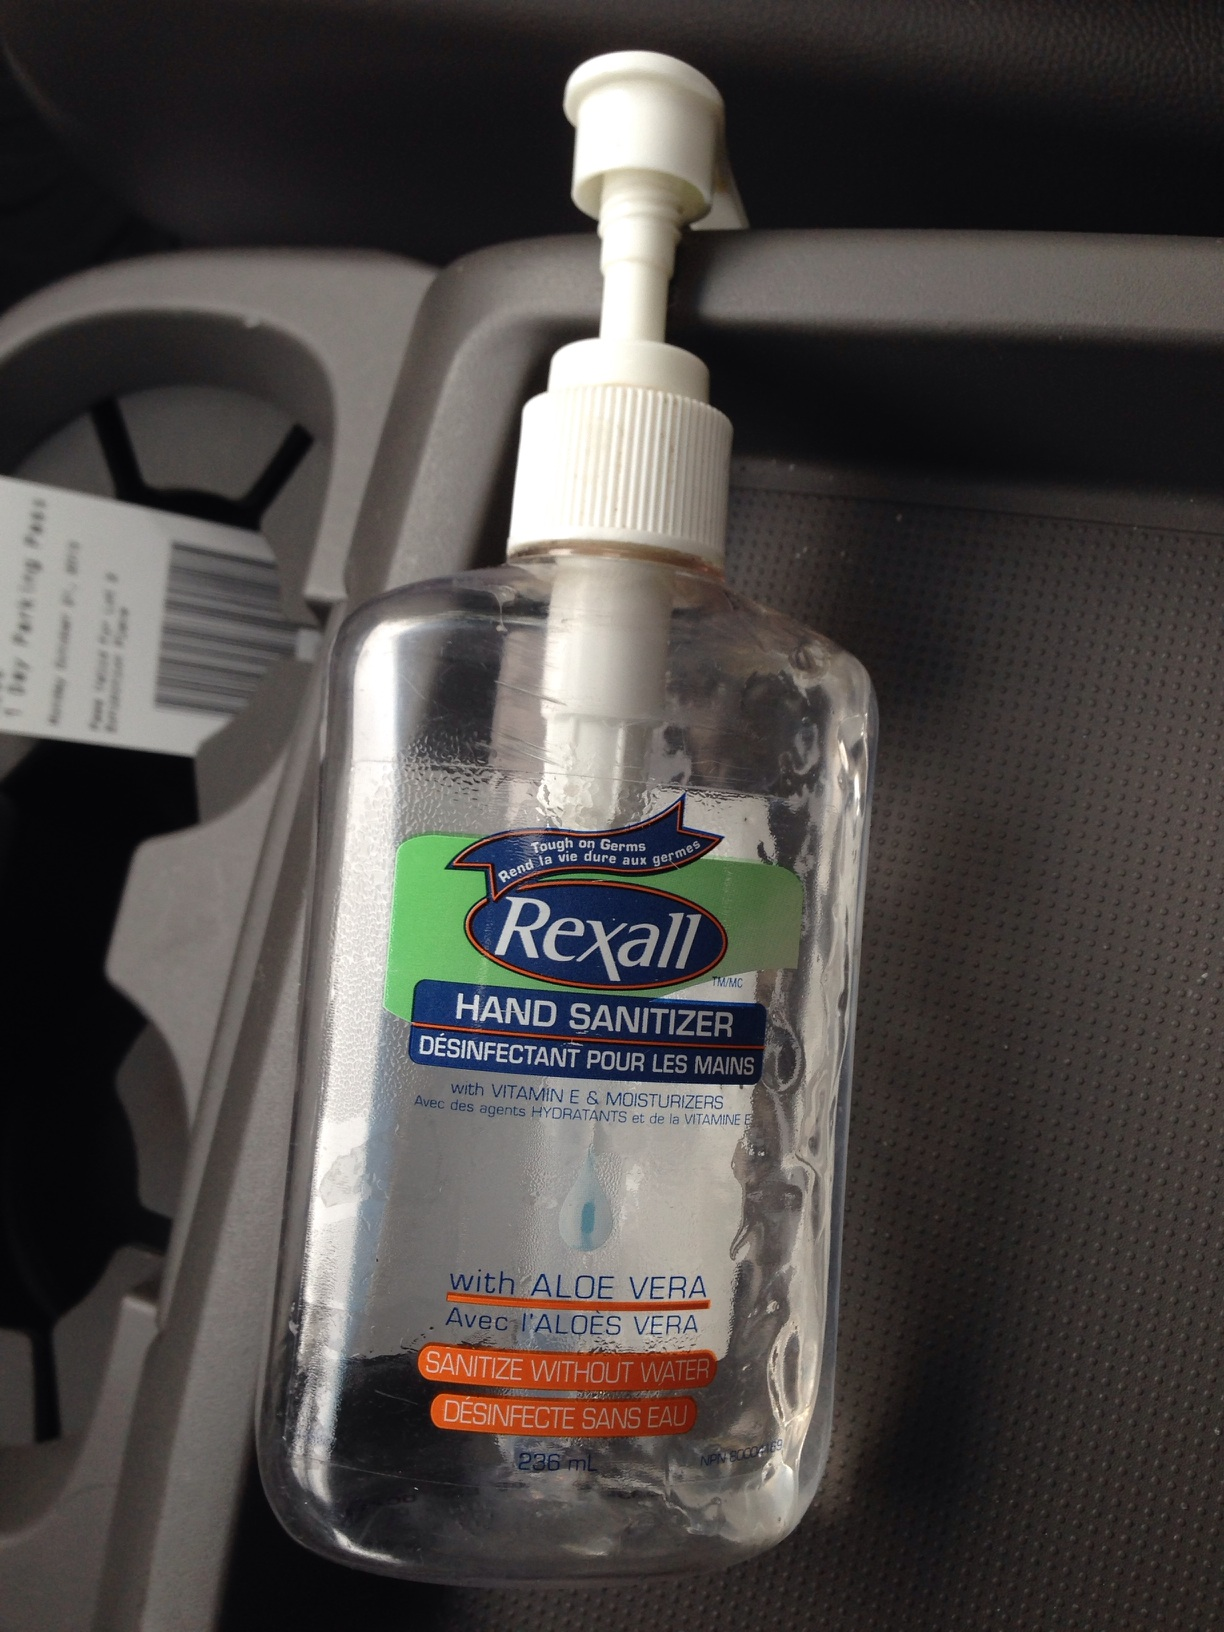What is this bottle? from Vizwiz hand sanitizer 